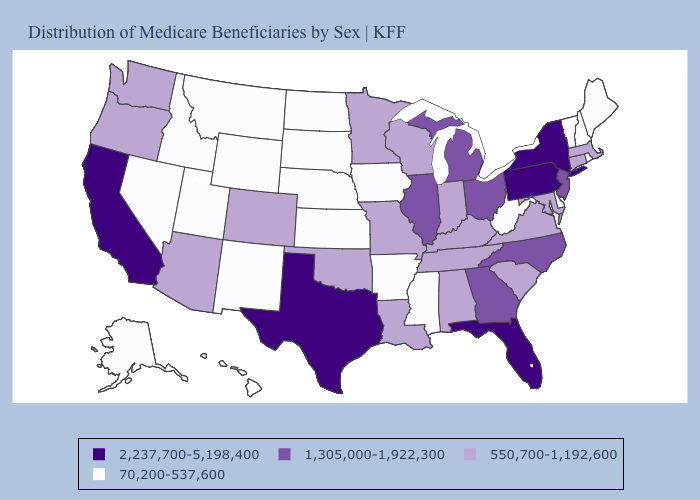What is the highest value in the USA?
Give a very brief answer. 2,237,700-5,198,400. Does Vermont have the lowest value in the USA?
Answer briefly. Yes. What is the value of Kansas?
Quick response, please. 70,200-537,600. Name the states that have a value in the range 2,237,700-5,198,400?
Keep it brief. California, Florida, New York, Pennsylvania, Texas. What is the lowest value in states that border Texas?
Short answer required. 70,200-537,600. What is the value of Iowa?
Concise answer only. 70,200-537,600. What is the lowest value in the USA?
Concise answer only. 70,200-537,600. What is the highest value in the MidWest ?
Give a very brief answer. 1,305,000-1,922,300. Among the states that border Rhode Island , which have the lowest value?
Concise answer only. Connecticut, Massachusetts. How many symbols are there in the legend?
Give a very brief answer. 4. What is the value of Louisiana?
Give a very brief answer. 550,700-1,192,600. Does New Jersey have the highest value in the Northeast?
Answer briefly. No. Name the states that have a value in the range 2,237,700-5,198,400?
Concise answer only. California, Florida, New York, Pennsylvania, Texas. What is the value of Louisiana?
Short answer required. 550,700-1,192,600. Does the map have missing data?
Answer briefly. No. 